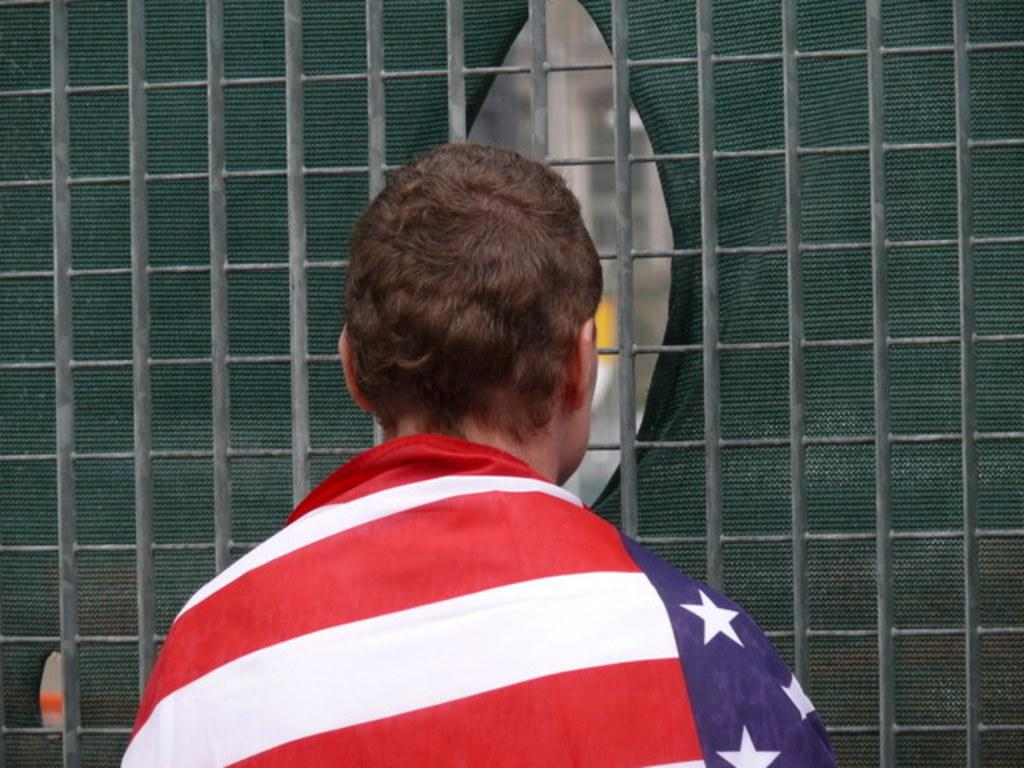What is the main subject of the image? There is a person in the image. How is the person positioned in relation to the camera? The person is facing away from the camera. What other object can be seen in the image? There is a flag of a country in the image. Can you describe the texture or material of any element in the image? There is a mesh in the image, which suggests a specific texture or material. How many sheep are visible in the image? There are no sheep present in the image. What position does the person hold in the organization represented by the flag? The image does not provide enough information to determine the person's position or role in any organization. 